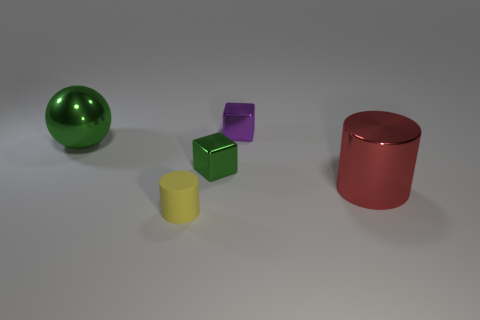Add 4 big things. How many objects exist? 9 Subtract all blocks. How many objects are left? 3 Subtract all shiny cylinders. Subtract all blocks. How many objects are left? 2 Add 2 red metallic objects. How many red metallic objects are left? 3 Add 2 yellow balls. How many yellow balls exist? 2 Subtract 0 yellow balls. How many objects are left? 5 